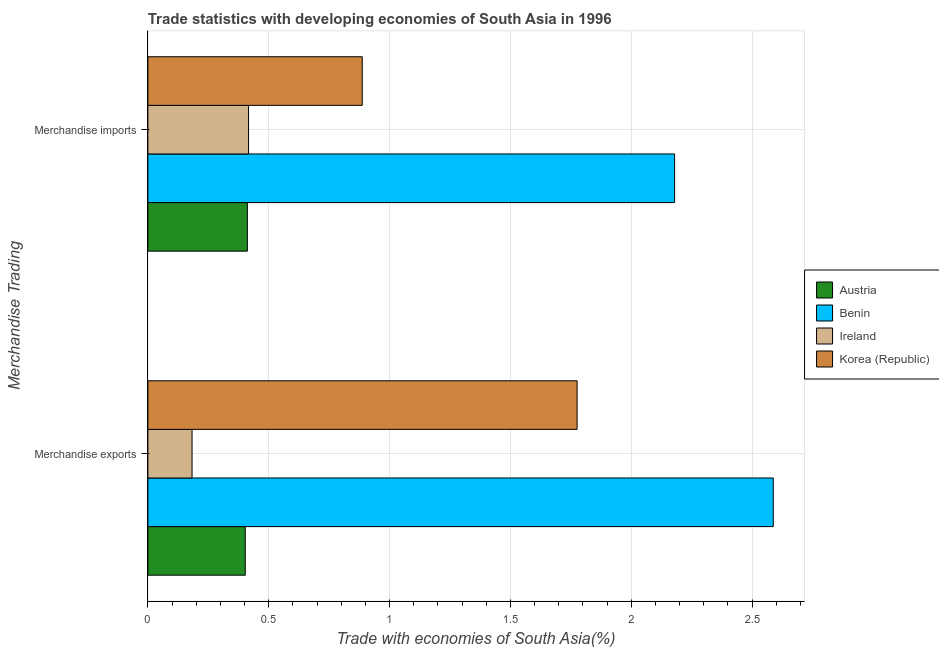How many groups of bars are there?
Provide a short and direct response. 2. Are the number of bars per tick equal to the number of legend labels?
Your answer should be very brief. Yes. Are the number of bars on each tick of the Y-axis equal?
Ensure brevity in your answer.  Yes. What is the merchandise exports in Austria?
Offer a very short reply. 0.4. Across all countries, what is the maximum merchandise exports?
Provide a short and direct response. 2.59. Across all countries, what is the minimum merchandise exports?
Your response must be concise. 0.18. In which country was the merchandise exports maximum?
Provide a short and direct response. Benin. What is the total merchandise exports in the graph?
Your response must be concise. 4.95. What is the difference between the merchandise imports in Ireland and that in Korea (Republic)?
Make the answer very short. -0.47. What is the difference between the merchandise exports in Austria and the merchandise imports in Korea (Republic)?
Your answer should be very brief. -0.48. What is the average merchandise exports per country?
Make the answer very short. 1.24. What is the difference between the merchandise exports and merchandise imports in Korea (Republic)?
Ensure brevity in your answer.  0.89. What is the ratio of the merchandise imports in Ireland to that in Austria?
Your answer should be very brief. 1.01. In how many countries, is the merchandise imports greater than the average merchandise imports taken over all countries?
Your response must be concise. 1. What does the 3rd bar from the bottom in Merchandise imports represents?
Offer a very short reply. Ireland. How many bars are there?
Ensure brevity in your answer.  8. What is the difference between two consecutive major ticks on the X-axis?
Ensure brevity in your answer.  0.5. Does the graph contain any zero values?
Your response must be concise. No. Where does the legend appear in the graph?
Offer a terse response. Center right. How many legend labels are there?
Your response must be concise. 4. How are the legend labels stacked?
Keep it short and to the point. Vertical. What is the title of the graph?
Give a very brief answer. Trade statistics with developing economies of South Asia in 1996. What is the label or title of the X-axis?
Offer a terse response. Trade with economies of South Asia(%). What is the label or title of the Y-axis?
Offer a terse response. Merchandise Trading. What is the Trade with economies of South Asia(%) of Austria in Merchandise exports?
Give a very brief answer. 0.4. What is the Trade with economies of South Asia(%) of Benin in Merchandise exports?
Provide a succinct answer. 2.59. What is the Trade with economies of South Asia(%) of Ireland in Merchandise exports?
Ensure brevity in your answer.  0.18. What is the Trade with economies of South Asia(%) of Korea (Republic) in Merchandise exports?
Give a very brief answer. 1.78. What is the Trade with economies of South Asia(%) in Austria in Merchandise imports?
Make the answer very short. 0.41. What is the Trade with economies of South Asia(%) of Benin in Merchandise imports?
Keep it short and to the point. 2.18. What is the Trade with economies of South Asia(%) in Ireland in Merchandise imports?
Your response must be concise. 0.42. What is the Trade with economies of South Asia(%) of Korea (Republic) in Merchandise imports?
Offer a very short reply. 0.89. Across all Merchandise Trading, what is the maximum Trade with economies of South Asia(%) in Austria?
Ensure brevity in your answer.  0.41. Across all Merchandise Trading, what is the maximum Trade with economies of South Asia(%) in Benin?
Offer a terse response. 2.59. Across all Merchandise Trading, what is the maximum Trade with economies of South Asia(%) of Ireland?
Give a very brief answer. 0.42. Across all Merchandise Trading, what is the maximum Trade with economies of South Asia(%) of Korea (Republic)?
Your answer should be compact. 1.78. Across all Merchandise Trading, what is the minimum Trade with economies of South Asia(%) in Austria?
Provide a short and direct response. 0.4. Across all Merchandise Trading, what is the minimum Trade with economies of South Asia(%) of Benin?
Provide a succinct answer. 2.18. Across all Merchandise Trading, what is the minimum Trade with economies of South Asia(%) in Ireland?
Your answer should be compact. 0.18. Across all Merchandise Trading, what is the minimum Trade with economies of South Asia(%) of Korea (Republic)?
Your response must be concise. 0.89. What is the total Trade with economies of South Asia(%) in Austria in the graph?
Your answer should be very brief. 0.81. What is the total Trade with economies of South Asia(%) of Benin in the graph?
Give a very brief answer. 4.77. What is the total Trade with economies of South Asia(%) of Ireland in the graph?
Your answer should be very brief. 0.6. What is the total Trade with economies of South Asia(%) in Korea (Republic) in the graph?
Provide a succinct answer. 2.66. What is the difference between the Trade with economies of South Asia(%) of Austria in Merchandise exports and that in Merchandise imports?
Offer a terse response. -0.01. What is the difference between the Trade with economies of South Asia(%) in Benin in Merchandise exports and that in Merchandise imports?
Ensure brevity in your answer.  0.41. What is the difference between the Trade with economies of South Asia(%) of Ireland in Merchandise exports and that in Merchandise imports?
Your answer should be very brief. -0.23. What is the difference between the Trade with economies of South Asia(%) in Korea (Republic) in Merchandise exports and that in Merchandise imports?
Provide a succinct answer. 0.89. What is the difference between the Trade with economies of South Asia(%) of Austria in Merchandise exports and the Trade with economies of South Asia(%) of Benin in Merchandise imports?
Provide a short and direct response. -1.78. What is the difference between the Trade with economies of South Asia(%) of Austria in Merchandise exports and the Trade with economies of South Asia(%) of Ireland in Merchandise imports?
Offer a very short reply. -0.01. What is the difference between the Trade with economies of South Asia(%) of Austria in Merchandise exports and the Trade with economies of South Asia(%) of Korea (Republic) in Merchandise imports?
Offer a terse response. -0.48. What is the difference between the Trade with economies of South Asia(%) in Benin in Merchandise exports and the Trade with economies of South Asia(%) in Ireland in Merchandise imports?
Your answer should be compact. 2.17. What is the difference between the Trade with economies of South Asia(%) in Benin in Merchandise exports and the Trade with economies of South Asia(%) in Korea (Republic) in Merchandise imports?
Ensure brevity in your answer.  1.7. What is the difference between the Trade with economies of South Asia(%) of Ireland in Merchandise exports and the Trade with economies of South Asia(%) of Korea (Republic) in Merchandise imports?
Keep it short and to the point. -0.7. What is the average Trade with economies of South Asia(%) of Austria per Merchandise Trading?
Your answer should be very brief. 0.41. What is the average Trade with economies of South Asia(%) of Benin per Merchandise Trading?
Give a very brief answer. 2.38. What is the average Trade with economies of South Asia(%) of Ireland per Merchandise Trading?
Offer a terse response. 0.3. What is the average Trade with economies of South Asia(%) of Korea (Republic) per Merchandise Trading?
Ensure brevity in your answer.  1.33. What is the difference between the Trade with economies of South Asia(%) in Austria and Trade with economies of South Asia(%) in Benin in Merchandise exports?
Keep it short and to the point. -2.18. What is the difference between the Trade with economies of South Asia(%) in Austria and Trade with economies of South Asia(%) in Ireland in Merchandise exports?
Your response must be concise. 0.22. What is the difference between the Trade with economies of South Asia(%) of Austria and Trade with economies of South Asia(%) of Korea (Republic) in Merchandise exports?
Offer a terse response. -1.37. What is the difference between the Trade with economies of South Asia(%) in Benin and Trade with economies of South Asia(%) in Ireland in Merchandise exports?
Keep it short and to the point. 2.4. What is the difference between the Trade with economies of South Asia(%) in Benin and Trade with economies of South Asia(%) in Korea (Republic) in Merchandise exports?
Ensure brevity in your answer.  0.81. What is the difference between the Trade with economies of South Asia(%) in Ireland and Trade with economies of South Asia(%) in Korea (Republic) in Merchandise exports?
Your answer should be very brief. -1.59. What is the difference between the Trade with economies of South Asia(%) in Austria and Trade with economies of South Asia(%) in Benin in Merchandise imports?
Offer a terse response. -1.77. What is the difference between the Trade with economies of South Asia(%) of Austria and Trade with economies of South Asia(%) of Ireland in Merchandise imports?
Make the answer very short. -0. What is the difference between the Trade with economies of South Asia(%) of Austria and Trade with economies of South Asia(%) of Korea (Republic) in Merchandise imports?
Offer a very short reply. -0.48. What is the difference between the Trade with economies of South Asia(%) of Benin and Trade with economies of South Asia(%) of Ireland in Merchandise imports?
Your answer should be compact. 1.76. What is the difference between the Trade with economies of South Asia(%) of Benin and Trade with economies of South Asia(%) of Korea (Republic) in Merchandise imports?
Make the answer very short. 1.29. What is the difference between the Trade with economies of South Asia(%) of Ireland and Trade with economies of South Asia(%) of Korea (Republic) in Merchandise imports?
Your answer should be very brief. -0.47. What is the ratio of the Trade with economies of South Asia(%) of Austria in Merchandise exports to that in Merchandise imports?
Offer a very short reply. 0.98. What is the ratio of the Trade with economies of South Asia(%) in Benin in Merchandise exports to that in Merchandise imports?
Your response must be concise. 1.19. What is the ratio of the Trade with economies of South Asia(%) in Ireland in Merchandise exports to that in Merchandise imports?
Offer a terse response. 0.44. What is the ratio of the Trade with economies of South Asia(%) in Korea (Republic) in Merchandise exports to that in Merchandise imports?
Provide a short and direct response. 2. What is the difference between the highest and the second highest Trade with economies of South Asia(%) in Austria?
Provide a short and direct response. 0.01. What is the difference between the highest and the second highest Trade with economies of South Asia(%) in Benin?
Give a very brief answer. 0.41. What is the difference between the highest and the second highest Trade with economies of South Asia(%) of Ireland?
Offer a terse response. 0.23. What is the difference between the highest and the second highest Trade with economies of South Asia(%) of Korea (Republic)?
Keep it short and to the point. 0.89. What is the difference between the highest and the lowest Trade with economies of South Asia(%) of Austria?
Make the answer very short. 0.01. What is the difference between the highest and the lowest Trade with economies of South Asia(%) in Benin?
Ensure brevity in your answer.  0.41. What is the difference between the highest and the lowest Trade with economies of South Asia(%) in Ireland?
Make the answer very short. 0.23. What is the difference between the highest and the lowest Trade with economies of South Asia(%) in Korea (Republic)?
Make the answer very short. 0.89. 